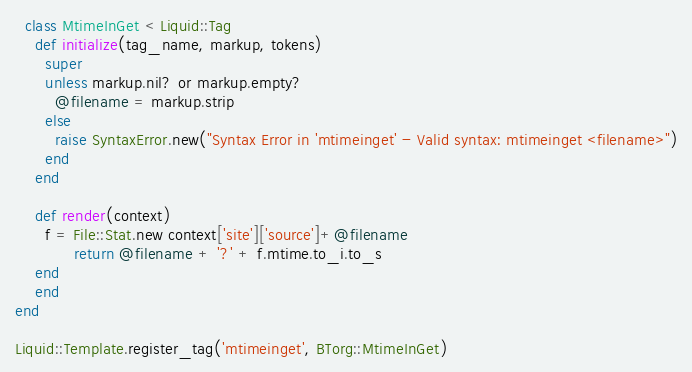<code> <loc_0><loc_0><loc_500><loc_500><_Ruby_>  class MtimeInGet < Liquid::Tag
    def initialize(tag_name, markup, tokens)
      super
      unless markup.nil? or markup.empty?
        @filename = markup.strip
      else
        raise SyntaxError.new("Syntax Error in 'mtimeinget' - Valid syntax: mtimeinget <filename>")
      end
    end

    def render(context)
      f = File::Stat.new context['site']['source']+@filename
			return @filename + '?' + f.mtime.to_i.to_s
    end
	end
end

Liquid::Template.register_tag('mtimeinget', BTorg::MtimeInGet)
</code> 